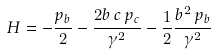<formula> <loc_0><loc_0><loc_500><loc_500>H = - \frac { p _ { b } } { 2 } - \frac { 2 b \, c \, p _ { c } } { \gamma ^ { 2 } } - \frac { 1 } { 2 } \frac { b ^ { 2 } \, p _ { b } } { \gamma ^ { 2 } }</formula> 